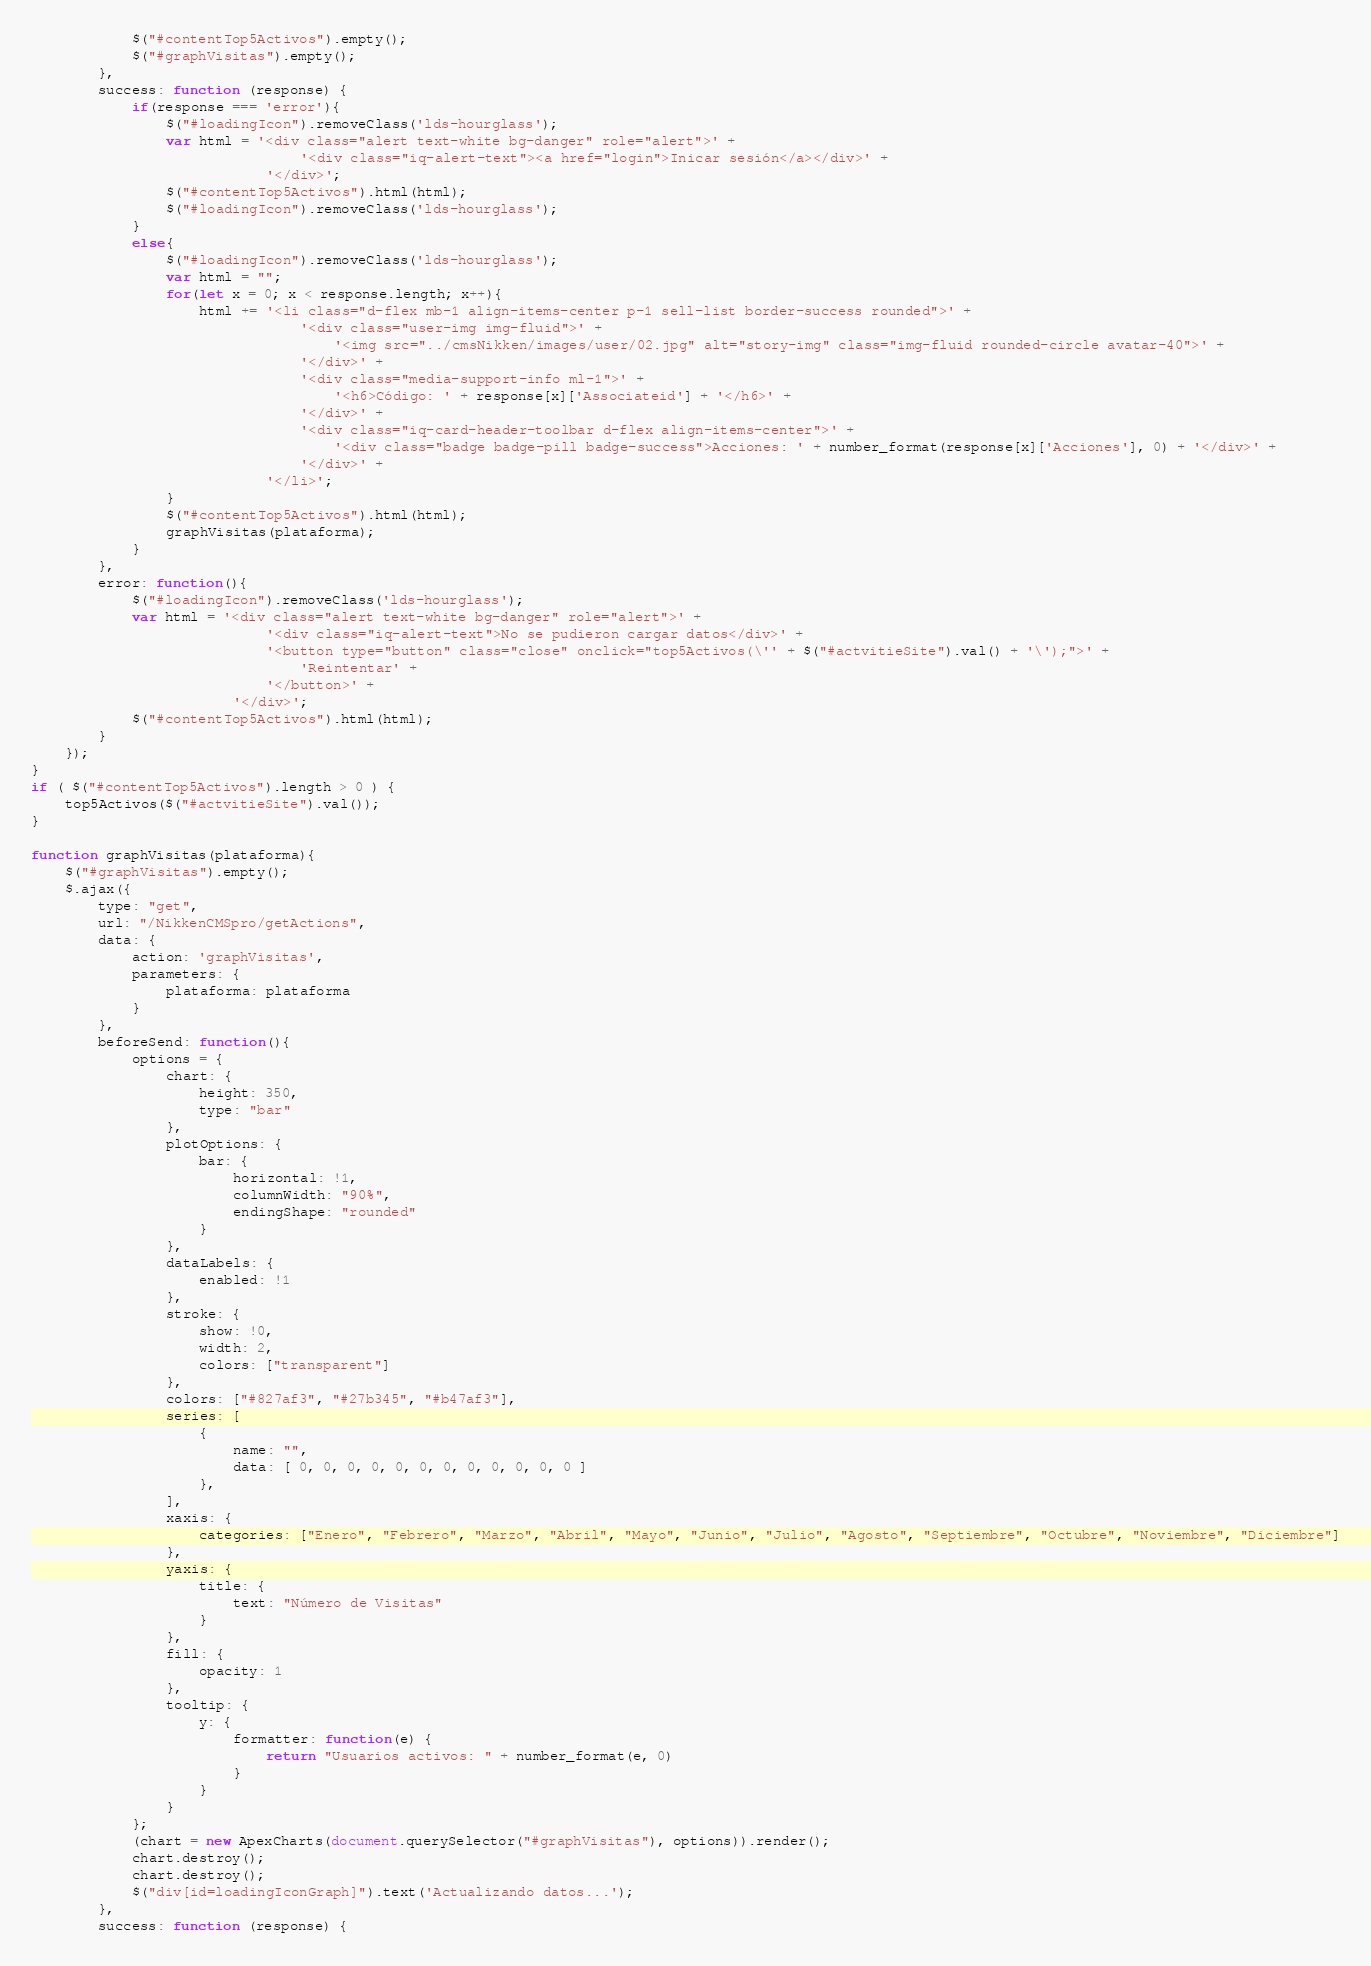<code> <loc_0><loc_0><loc_500><loc_500><_JavaScript_>            $("#contentTop5Activos").empty();
            $("#graphVisitas").empty();
        },
        success: function (response) {
            if(response === 'error'){
                $("#loadingIcon").removeClass('lds-hourglass');
                var html = '<div class="alert text-white bg-danger" role="alert">' +
                                '<div class="iq-alert-text"><a href="login">Inicar sesión</a></div>' +
                            '</div>';
                $("#contentTop5Activos").html(html);
                $("#loadingIcon").removeClass('lds-hourglass');
            }
            else{
                $("#loadingIcon").removeClass('lds-hourglass');
                var html = "";
                for(let x = 0; x < response.length; x++){
                    html += '<li class="d-flex mb-1 align-items-center p-1 sell-list border-success rounded">' +
                                '<div class="user-img img-fluid">' +
                                    '<img src="../cmsNikken/images/user/02.jpg" alt="story-img" class="img-fluid rounded-circle avatar-40">' +
                                '</div>' +
                                '<div class="media-support-info ml-1">' +
                                    '<h6>Código: ' + response[x]['Associateid'] + '</h6>' +
                                '</div>' +
                                '<div class="iq-card-header-toolbar d-flex align-items-center">' +
                                    '<div class="badge badge-pill badge-success">Acciones: ' + number_format(response[x]['Acciones'], 0) + '</div>' +
                                '</div>' +
                            '</li>';
                }
                $("#contentTop5Activos").html(html);
                graphVisitas(plataforma);
            }
        },
        error: function(){
            $("#loadingIcon").removeClass('lds-hourglass');
            var html = '<div class="alert text-white bg-danger" role="alert">' +
                            '<div class="iq-alert-text">No se pudieron cargar datos</div>' +
                            '<button type="button" class="close" onclick="top5Activos(\'' + $("#actvitieSite").val() + '\');">' +
                                'Reintentar' +
                            '</button>' +
                        '</div>';
            $("#contentTop5Activos").html(html);
        }
    });
}
if ( $("#contentTop5Activos").length > 0 ) {
    top5Activos($("#actvitieSite").val());
}

function graphVisitas(plataforma){
    $("#graphVisitas").empty();
    $.ajax({
        type: "get",
        url: "/NikkenCMSpro/getActions",
        data: {
            action: 'graphVisitas',
            parameters: {
                plataforma: plataforma
            }
        },
        beforeSend: function(){
            options = {
                chart: {
                    height: 350,
                    type: "bar"
                },
                plotOptions: {
                    bar: {
                        horizontal: !1,
                        columnWidth: "90%",
                        endingShape: "rounded"
                    }
                },
                dataLabels: {
                    enabled: !1
                },
                stroke: {
                    show: !0,
                    width: 2,
                    colors: ["transparent"]
                },
                colors: ["#827af3", "#27b345", "#b47af3"],
                series: [
                    {
                        name: "",
                        data: [ 0, 0, 0, 0, 0, 0, 0, 0, 0, 0, 0, 0 ]
                    },
                ],
                xaxis: {
                    categories: ["Enero", "Febrero", "Marzo", "Abril", "Mayo", "Junio", "Julio", "Agosto", "Septiembre", "Octubre", "Noviembre", "Diciembre"]
                },
                yaxis: {
                    title: {
                        text: "Número de Visitas"
                    }
                },
                fill: {
                    opacity: 1
                },
                tooltip: {
                    y: {
                        formatter: function(e) {
                            return "Usuarios activos: " + number_format(e, 0)
                        }
                    }
                }
            };
            (chart = new ApexCharts(document.querySelector("#graphVisitas"), options)).render();
            chart.destroy();
            chart.destroy();
            $("div[id=loadingIconGraph]").text('Actualizando datos...');
        },
        success: function (response) {</code> 